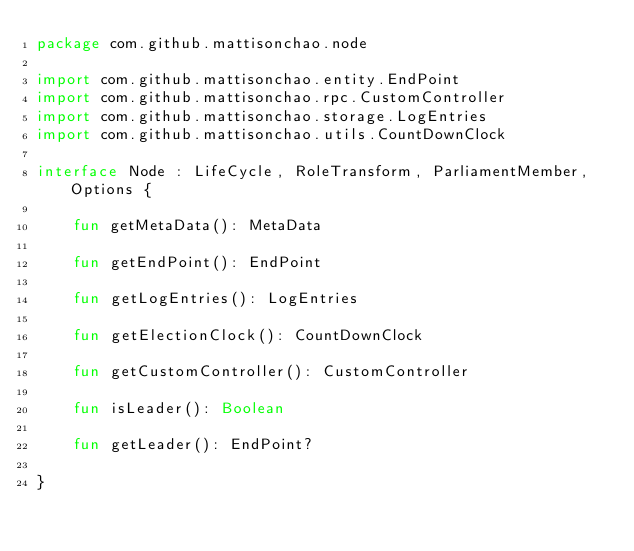Convert code to text. <code><loc_0><loc_0><loc_500><loc_500><_Kotlin_>package com.github.mattisonchao.node

import com.github.mattisonchao.entity.EndPoint
import com.github.mattisonchao.rpc.CustomController
import com.github.mattisonchao.storage.LogEntries
import com.github.mattisonchao.utils.CountDownClock

interface Node : LifeCycle, RoleTransform, ParliamentMember, Options {

    fun getMetaData(): MetaData

    fun getEndPoint(): EndPoint

    fun getLogEntries(): LogEntries

    fun getElectionClock(): CountDownClock

    fun getCustomController(): CustomController

    fun isLeader(): Boolean

    fun getLeader(): EndPoint?

}</code> 